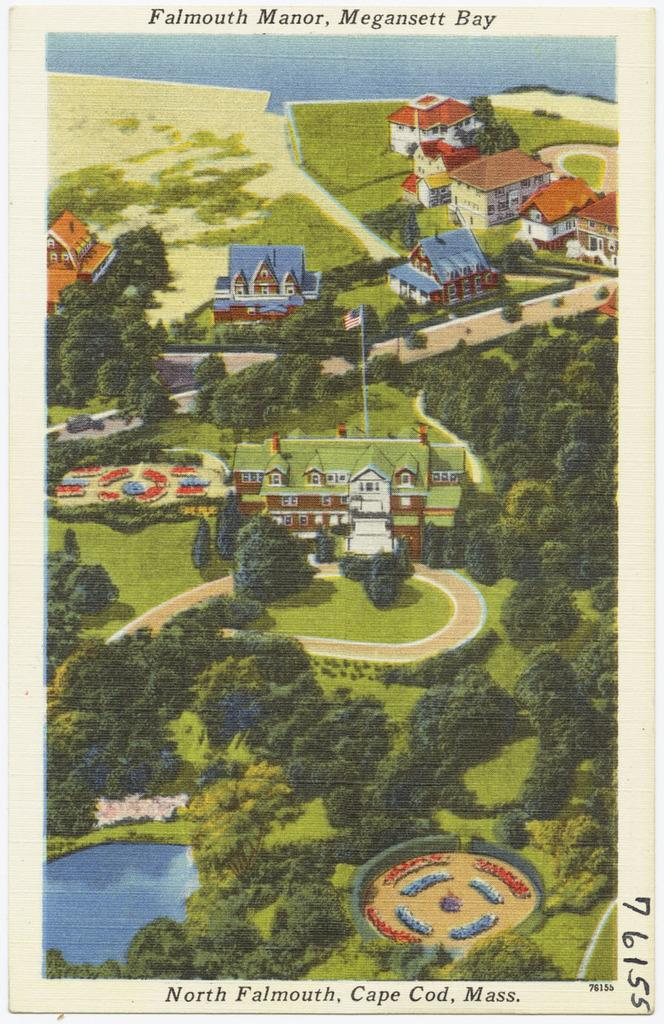<image>
Relay a brief, clear account of the picture shown. An old printed picture shows the layout an home of the Falmouth Manor. 